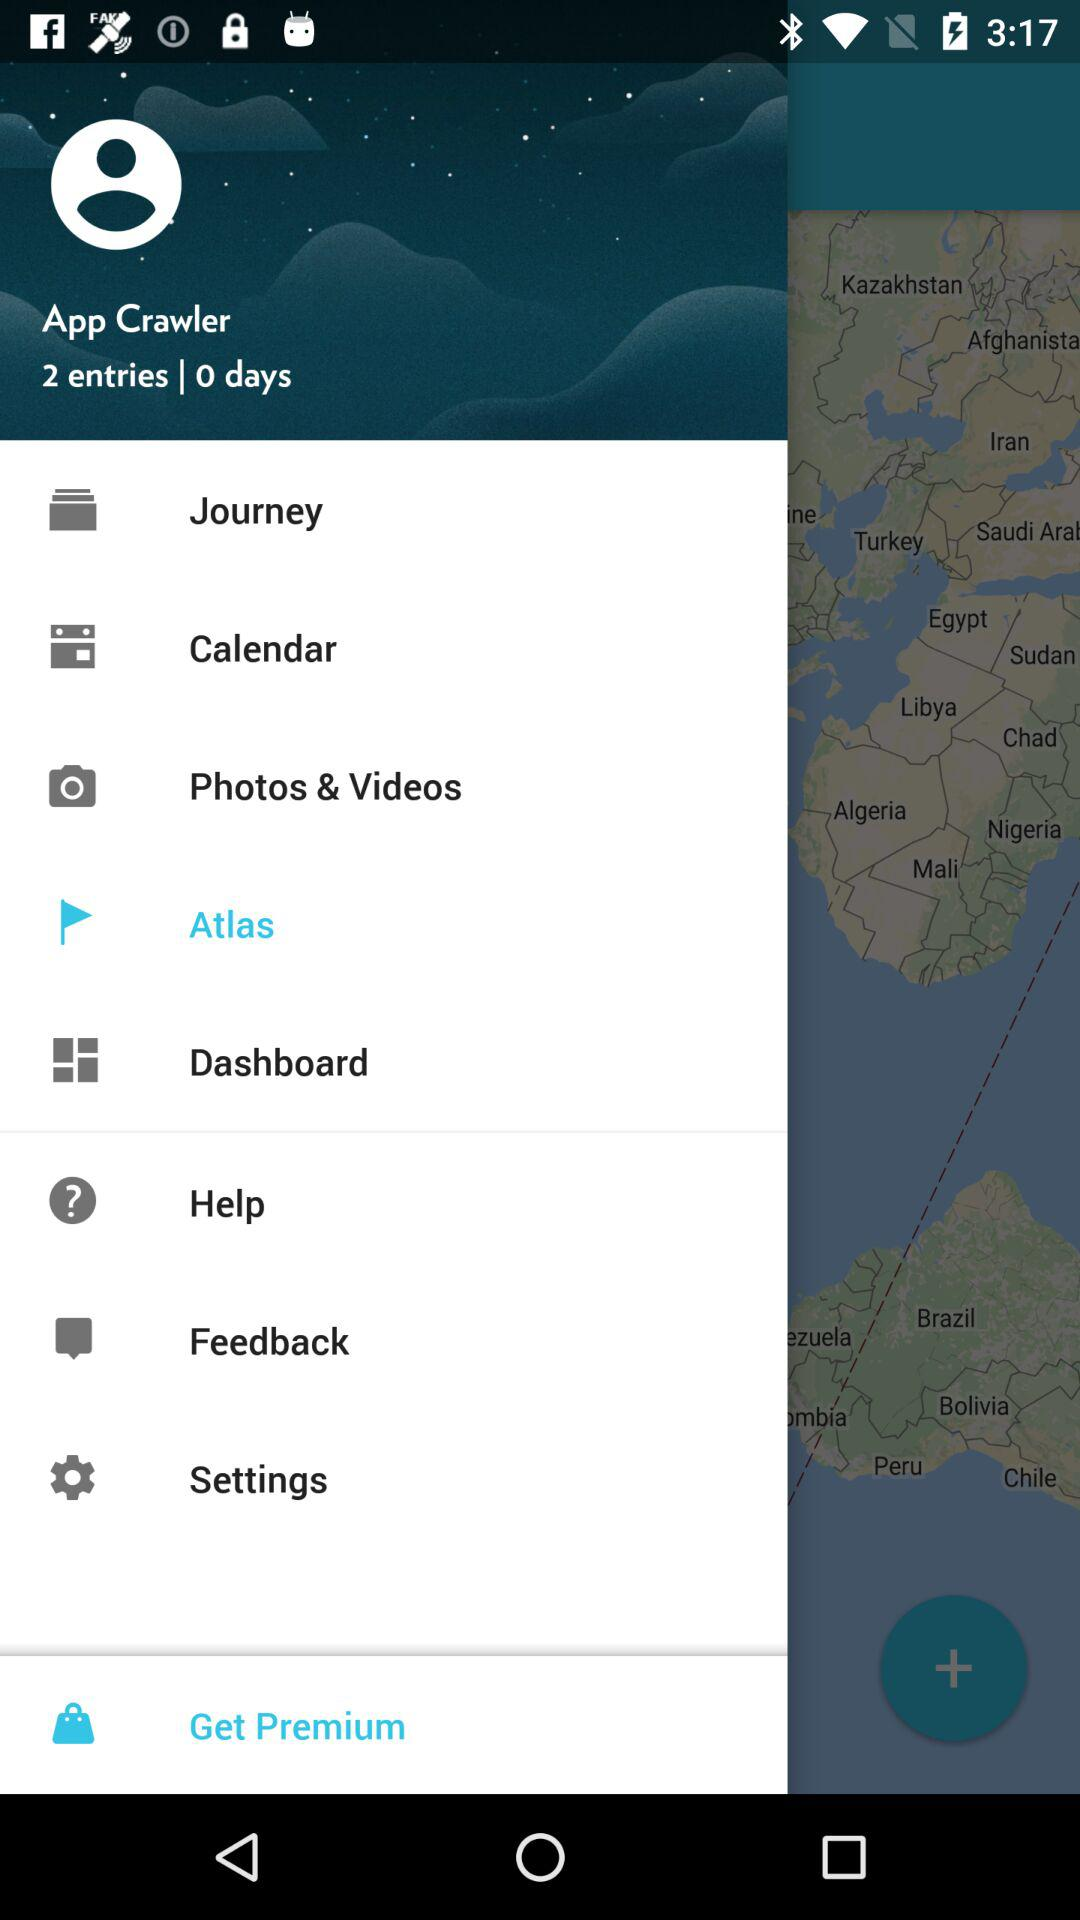How many notifications are there in "Settings"?
When the provided information is insufficient, respond with <no answer>. <no answer> 